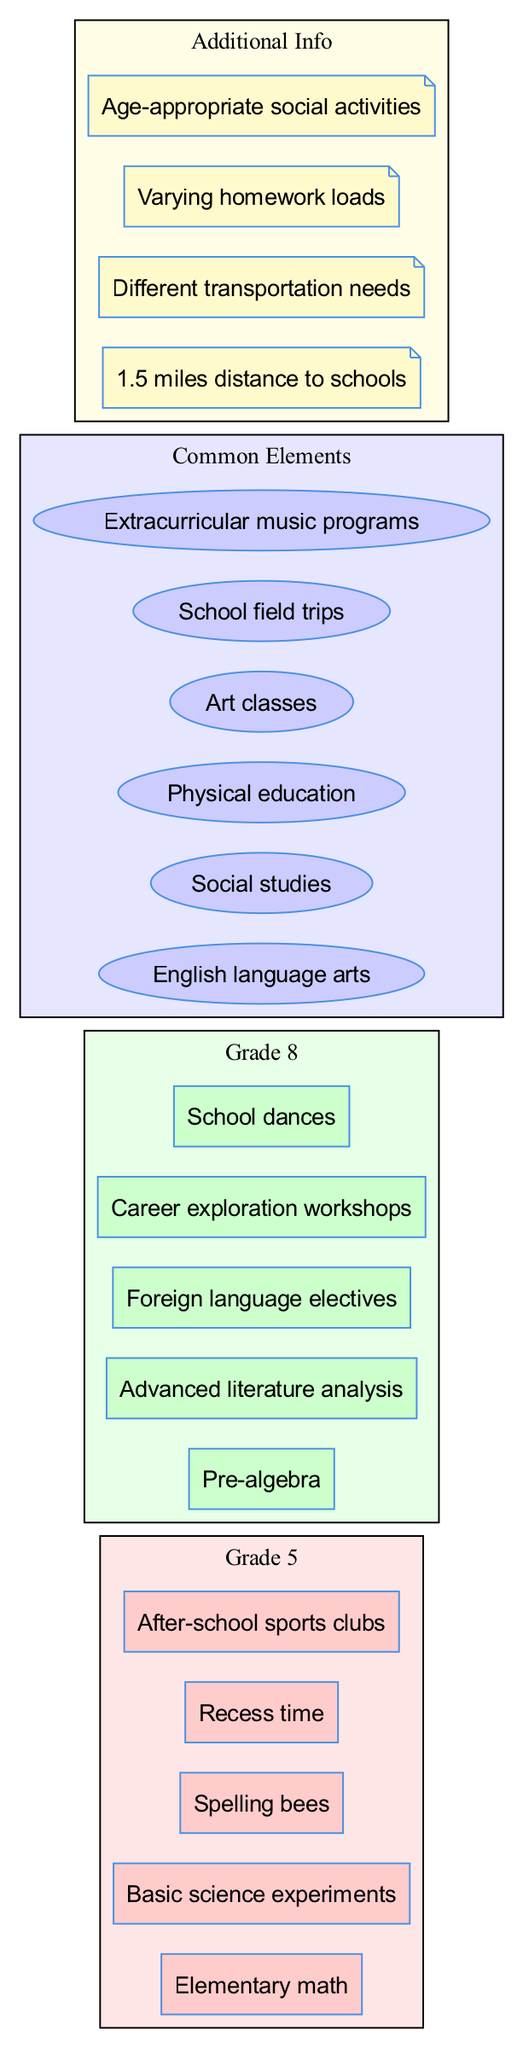What unique academic subject is only in Grade 5? In the Venn diagram, we can see the unique elements for Grade 5, which include "Elementary math." Since this subject is listed solely under Grade 5 and not in the common elements or Grade 8 unique elements, it is the answer.
Answer: Elementary math How many unique extracurricular activities are there for Grade 8? The Venn diagram displays the unique elements for Grade 8 students, which lists five specific extracurricular activities. Therefore, we count the items in that section to find the answer.
Answer: 5 What is a common subject that both grades study? By examining the 'Common Elements' section of the Venn diagram, we find subjects that both Grade 5 and Grade 8 students engage in. "English language arts" is one such subject shared between the two grades.
Answer: English language arts Which grade has "Career exploration workshops" as a unique activity? In the Venn diagram, we look at the unique elements of each grade. The phrase "Career exploration workshops" is found only in the unique section for Grade 8, making it specific to that grade.
Answer: Grade 8 How many additional information points are listed in the diagram? The diagram has a section titled 'Additional Info,' which contains four specific statements. Therefore, we simply count the items in that section to determine how many points are presented.
Answer: 4 What type of subjects are included under 'common elements'? The common elements section of the Venn diagram includes subjects that both grades study. They involve a mix of language arts, social studies, physical education, art, and music. Therefore, comprehensively evaluating them reveals they are various academic subjects.
Answer: Various academic subjects Which unique activity is specific to Grade 5? In the Venn diagram, the unique elements listed for Grade 5 include "Spelling bees." Since this is not found anywhere else in the diagram, it distinctly characterizes Grade 5 activities.
Answer: Spelling bees What is noted about the transportation needs related to school? In the 'Additional Info' section of the diagram, there is a specific mention of "Different transportation needs," suggesting variations based on the grades, distance, or other factors related to school transportation.
Answer: Different transportation needs What is a unique subject taught to eighth graders? The Venn diagram indicates that "Advanced literature analysis" is a subject uniquely taught to Grade 8 and does not appear in the Grade 5 curriculum. Thus, this subject represents the uniqueness for that grade level.
Answer: Advanced literature analysis 